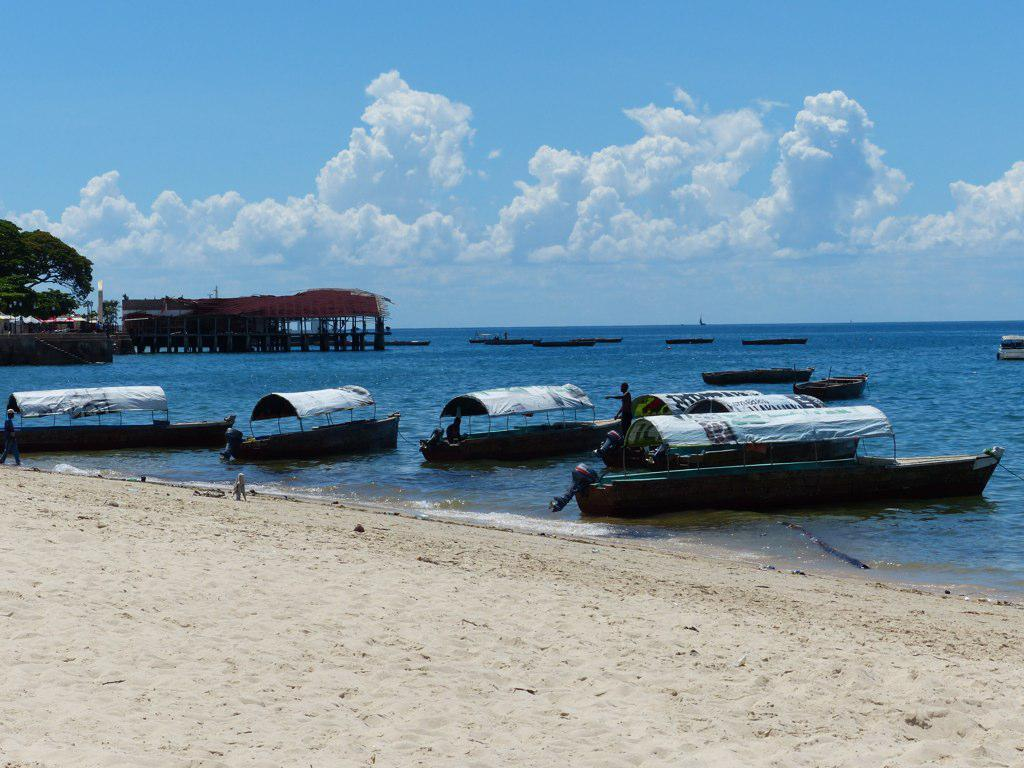What type of surface is visible in the foreground of the image? There is a sand surface in the image. What is located behind the sand surface? There is a water surface behind the sand surface. What can be seen floating on the water surface? There are boats on the water. Where is the tree located in the image? The tree is on the left side of the image. Who is the creator of the boats in the image? There is no information about the creator of the boats in the image. Can you see a man walking on the sand surface in the image? There is no man visible on the sand surface in the image. 